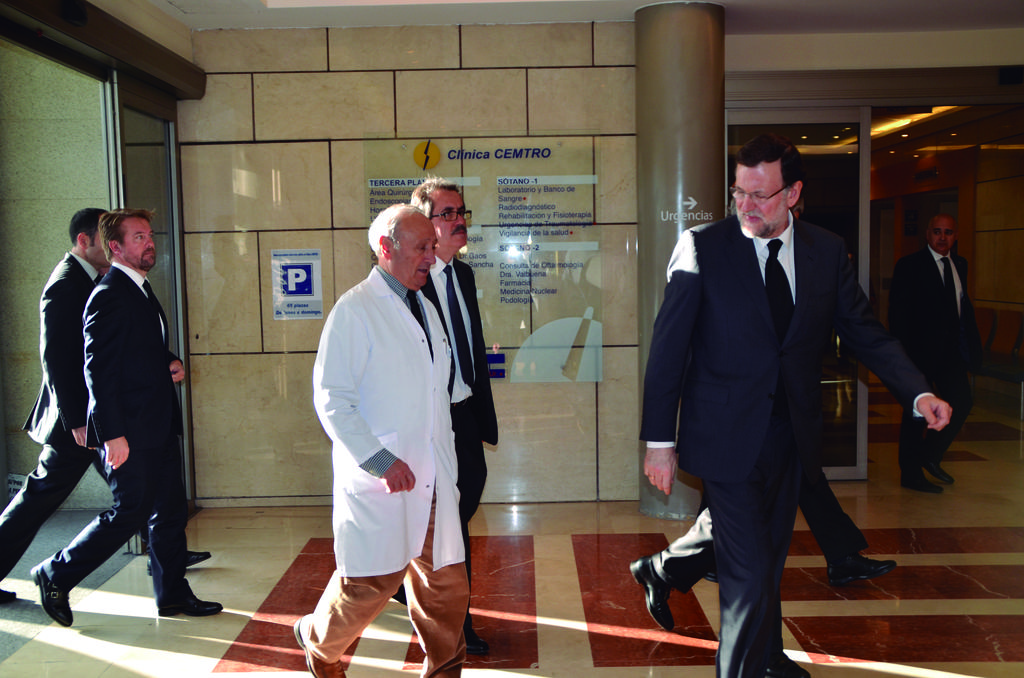What are the people in the image doing? The people in the image are walking on the floor. What can be seen on the ceiling in the image? There is a light on the ceiling. What is present in the background of the image? There is a board and a poster with text on the wall in the background. What is the steepness of the slope in the image? There is no slope present in the image; it features people walking on a flat floor. How far away is the string in the image? There is no string present in the image. 